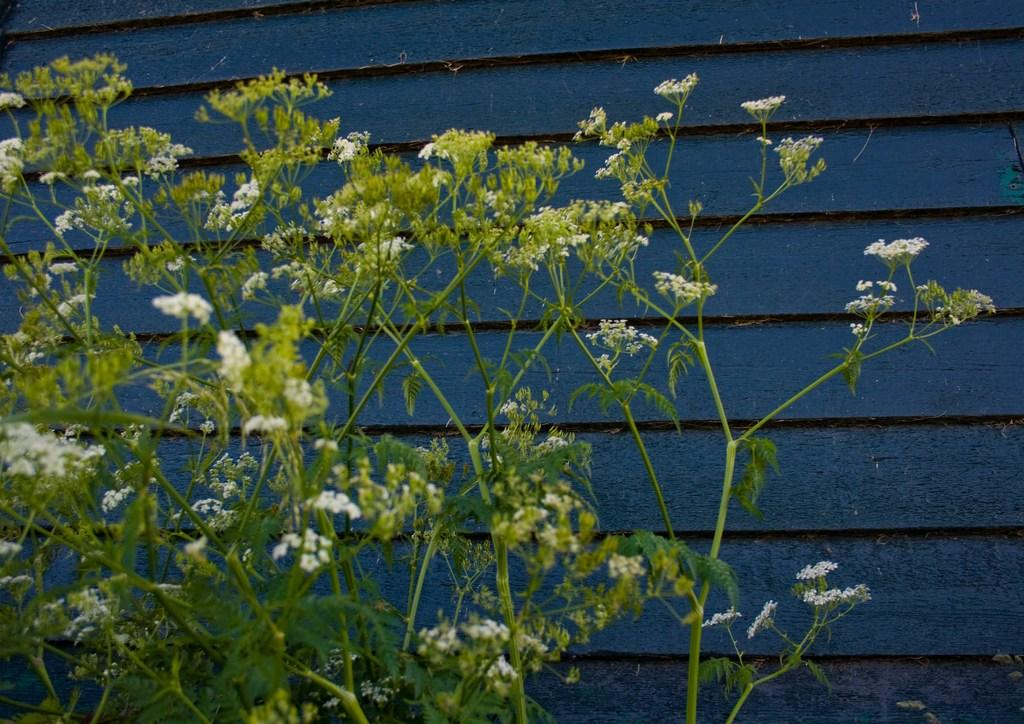What type of plants are in the image? There are plants with flowers in the image. What other features do the plants have? The plants have leaves. What can be seen in the background of the image? There is a wooden wall in the background of the image. How is the wooden wall decorated? The wooden wall is painted blue. Are there any pests visible on the plants in the image? There is no mention of pests in the image, so we cannot determine if any are any present. What type of playground equipment can be seen in the image? There is no playground equipment present in the image. 